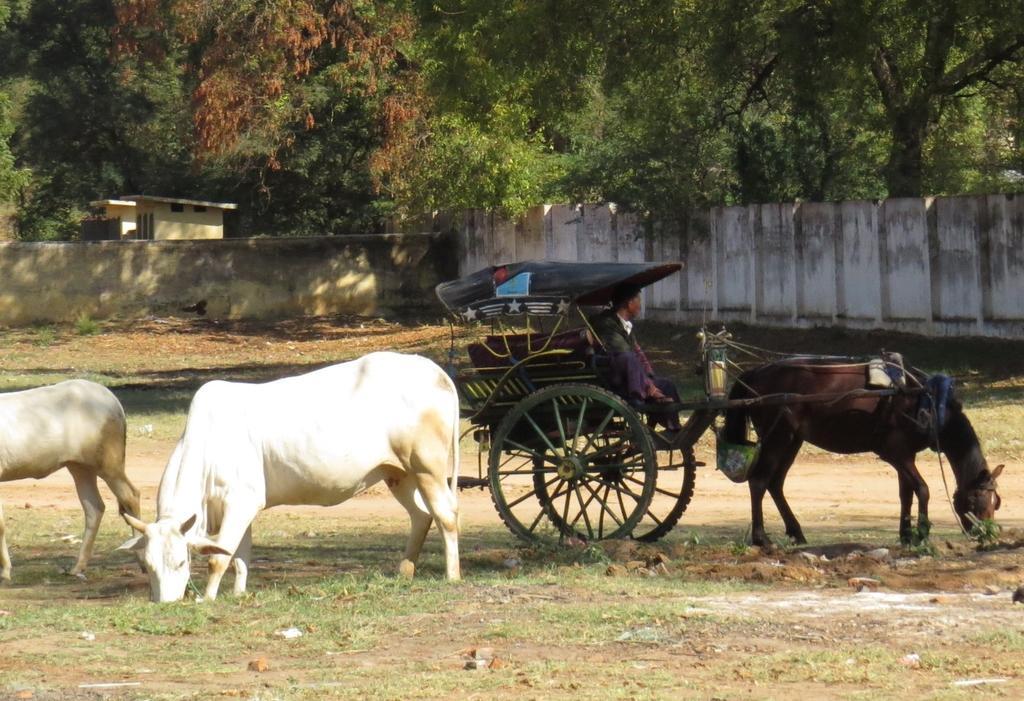In one or two sentences, can you explain what this image depicts? In this picture, we see a man is riding a horse cart. On the left side, we see two cows which are grazing the grass. At the bottom of the picture, we see the grass. In the background, we see a wall. Behind that, we see a building in white color. There are trees in the background. 